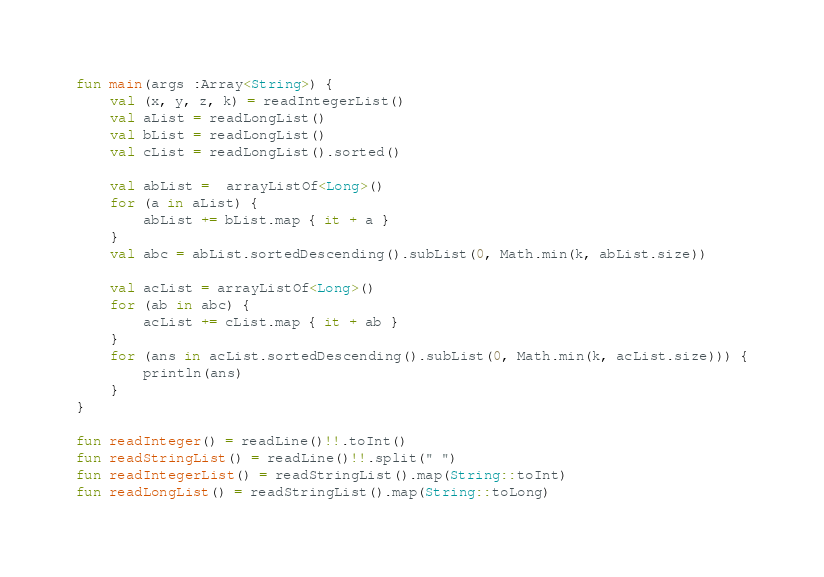<code> <loc_0><loc_0><loc_500><loc_500><_Kotlin_>fun main(args :Array<String>) {
    val (x, y, z, k) = readIntegerList()
    val aList = readLongList()
    val bList = readLongList()
    val cList = readLongList().sorted()

    val abList =  arrayListOf<Long>()
    for (a in aList) {
        abList += bList.map { it + a }
    }
    val abc = abList.sortedDescending().subList(0, Math.min(k, abList.size))

    val acList = arrayListOf<Long>()
    for (ab in abc) {
        acList += cList.map { it + ab }
    }
    for (ans in acList.sortedDescending().subList(0, Math.min(k, acList.size))) {
        println(ans)
    }
}

fun readInteger() = readLine()!!.toInt()
fun readStringList() = readLine()!!.split(" ")
fun readIntegerList() = readStringList().map(String::toInt)
fun readLongList() = readStringList().map(String::toLong)
</code> 